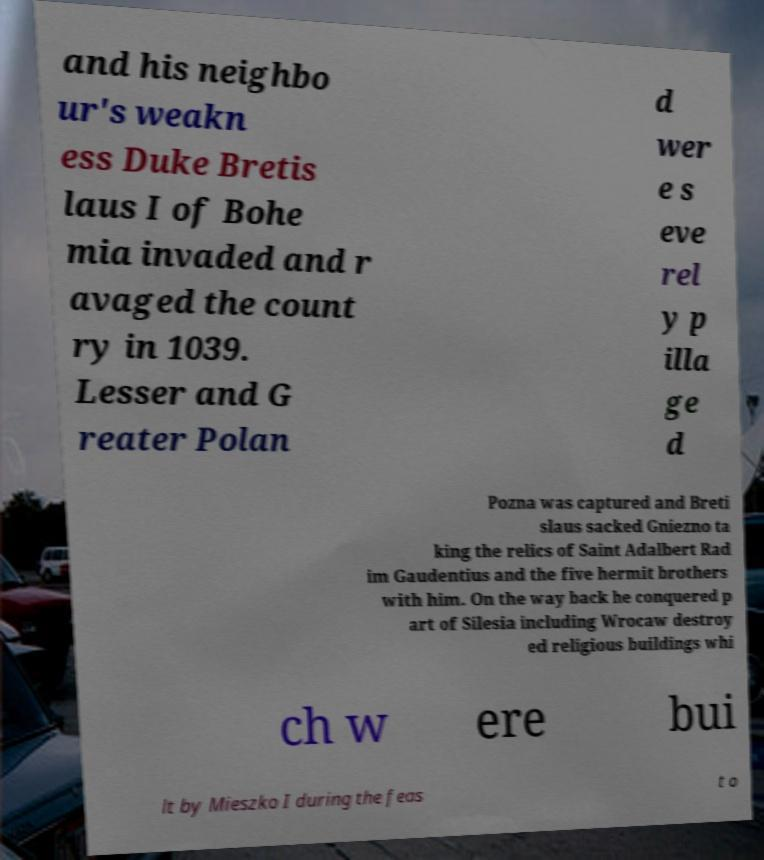I need the written content from this picture converted into text. Can you do that? and his neighbo ur's weakn ess Duke Bretis laus I of Bohe mia invaded and r avaged the count ry in 1039. Lesser and G reater Polan d wer e s eve rel y p illa ge d Pozna was captured and Breti slaus sacked Gniezno ta king the relics of Saint Adalbert Rad im Gaudentius and the five hermit brothers with him. On the way back he conquered p art of Silesia including Wrocaw destroy ed religious buildings whi ch w ere bui lt by Mieszko I during the feas t o 